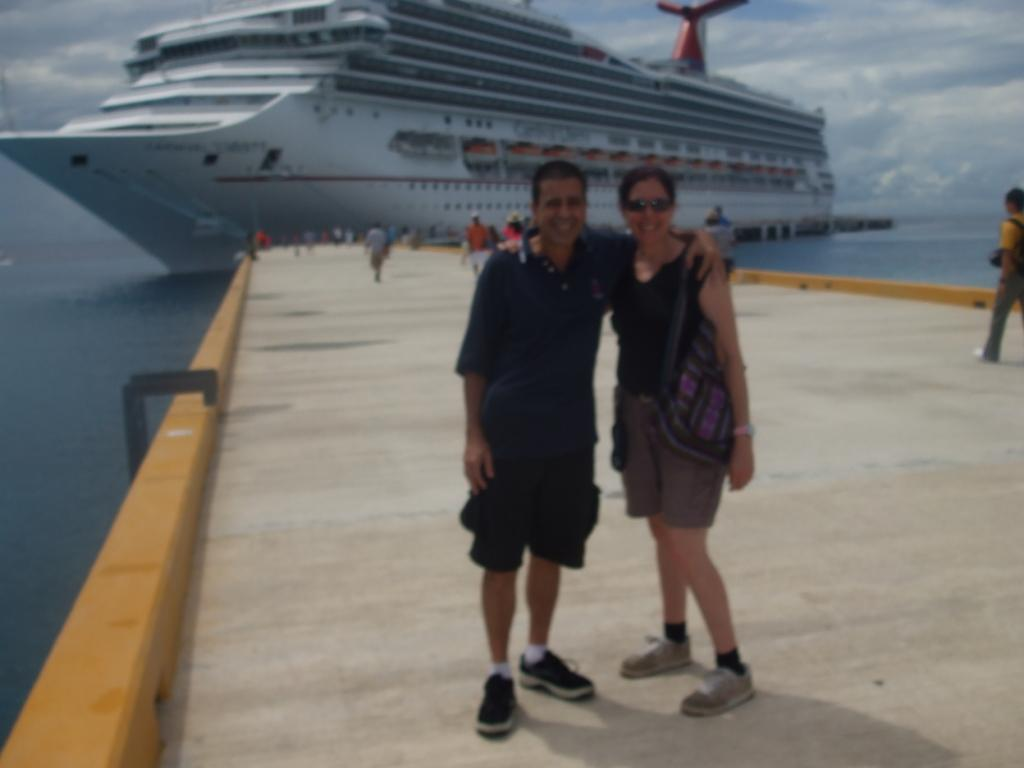What is the main subject in the image? There is a ship on the water body in the image. Where is the ship located in relation to the path? The ship is on the foreground of the path. How would you describe the sky in the image? The sky is cloudy in the image. What type of bone can be seen in the image? There is no bone present in the image; it features a ship on a water body with a cloudy sky. 